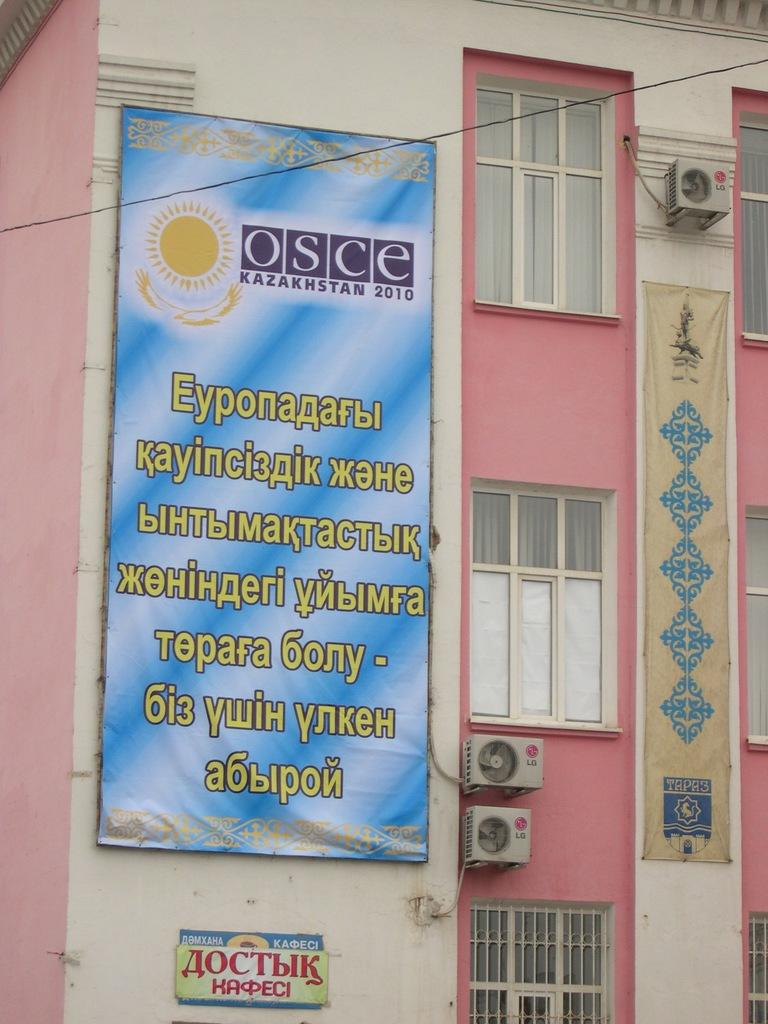What type of structure is visible in the image? There is a building in the image. What colors are used on the building? The building has white and pink colors. What can be seen on the building besides its color? There are AC outdoor units on the building. Is there any signage or advertisement on the building? Yes, there is a banner fixed to the wall of the building. What type of poison is being advertised on the banner? There is no poison mentioned or advertised on the banner; it is not present in the image. Can you describe the face of the person holding the pencil in the image? There is no person holding a pencil in the image; it is not present. 